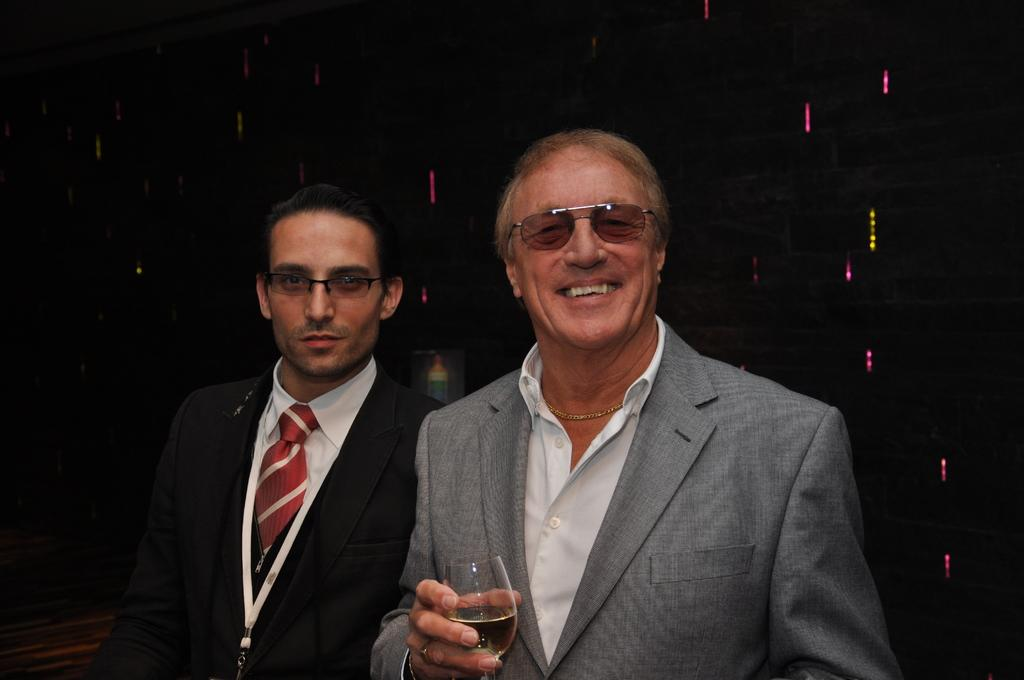What is the main subject in the middle of the image? There is a man in the middle of the image. What is the man in the middle holding? The man in the middle is holding a wine glass. Who is beside the first man? There is another man beside the first man. What type of clothing is the second man wearing? The second man is wearing a tie, a shirt, and a coat. What sound does the cat make in the image? There is no cat present in the image, so it is not possible to determine the sound it might make. 